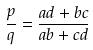Convert formula to latex. <formula><loc_0><loc_0><loc_500><loc_500>\frac { p } { q } = \frac { a d + b c } { a b + c d }</formula> 